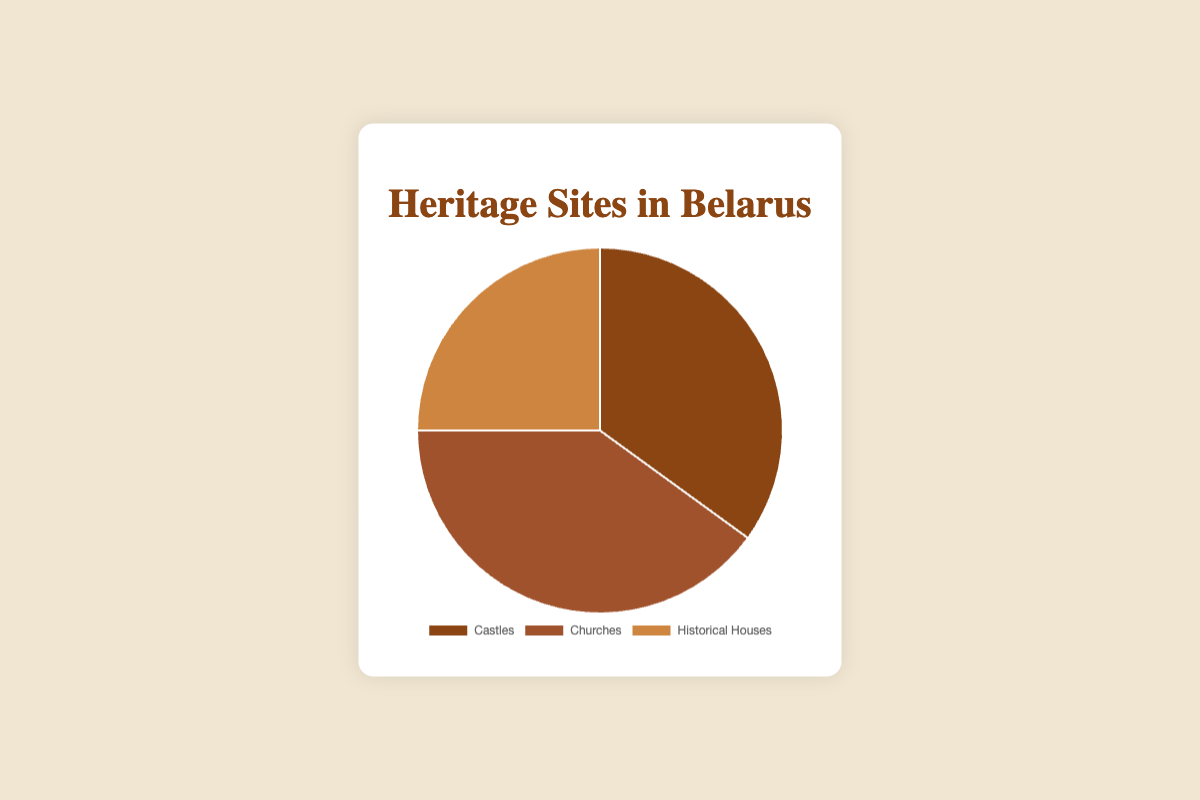Which type of heritage site makes up the largest percentage in Belarus? The pie chart shows the percentages of different types of heritage sites. Churches have the largest segment with 40%.
Answer: Churches Which type of heritage site is represented by the smallest percentage? The pie chart shows the percentages of different types of heritage sites. Historical houses occupy the smallest segment with 25%.
Answer: Historical houses What is the percentage difference between churches and historical houses? From the pie chart, churches constitute 40% and historical houses 25%. The difference is calculated as 40% - 25% = 15%.
Answer: 15% Are there more castles or churches as heritage sites? The pie chart shows that castles account for 35% while churches account for 40%. Since 40% is greater than 35%, there are more churches than castles.
Answer: Churches Sum the percentages of castles and historical houses. What does it represent? The pie chart indicates that castles make up 35% and historical houses 25%. The sum is 35% + 25% = 60%. This represents the combined percentage of heritage sites that are either castles or historical houses.
Answer: 60% Compare the combined percentage of castles and historical houses to that of churches. Is it greater or smaller? From the pie chart, castles and historical houses together make up 35% + 25% = 60%. Churches alone make up 40%. Since 60% is greater than 40%, the combined percentage of castles and historical houses is greater.
Answer: Greater What color represents the churches in the pie chart? The pie chart uses different colors for each type of heritage site. The section for churches is colored in a brownish shade.
Answer: Brownish How much more does the largest category exceed the smallest category in percentage? The largest category is churches at 40%, and the smallest is historical houses at 25%. The difference is 40% - 25% = 15%.
Answer: 15% If a new type of heritage site was added and took up 10% of the pie chart, what would be the new percentage for castles, assuming they remain unchanged? Currently, castles occupy 35% of the pie chart. Adding a new type that takes up 10% would change the total percentage to 100% + 10% = 110%. To find the new percentage for castles, the percentage remains as 35% in the enlarged total.
Answer: 35% What is the average percentage of the three types of heritage sites in Belarus? The pie chart shows the percentages for castles (35%), churches (40%), and historical houses (25%). The average is calculated as (35% + 40% + 25%) / 3 = 33.33%.
Answer: 33.33% 